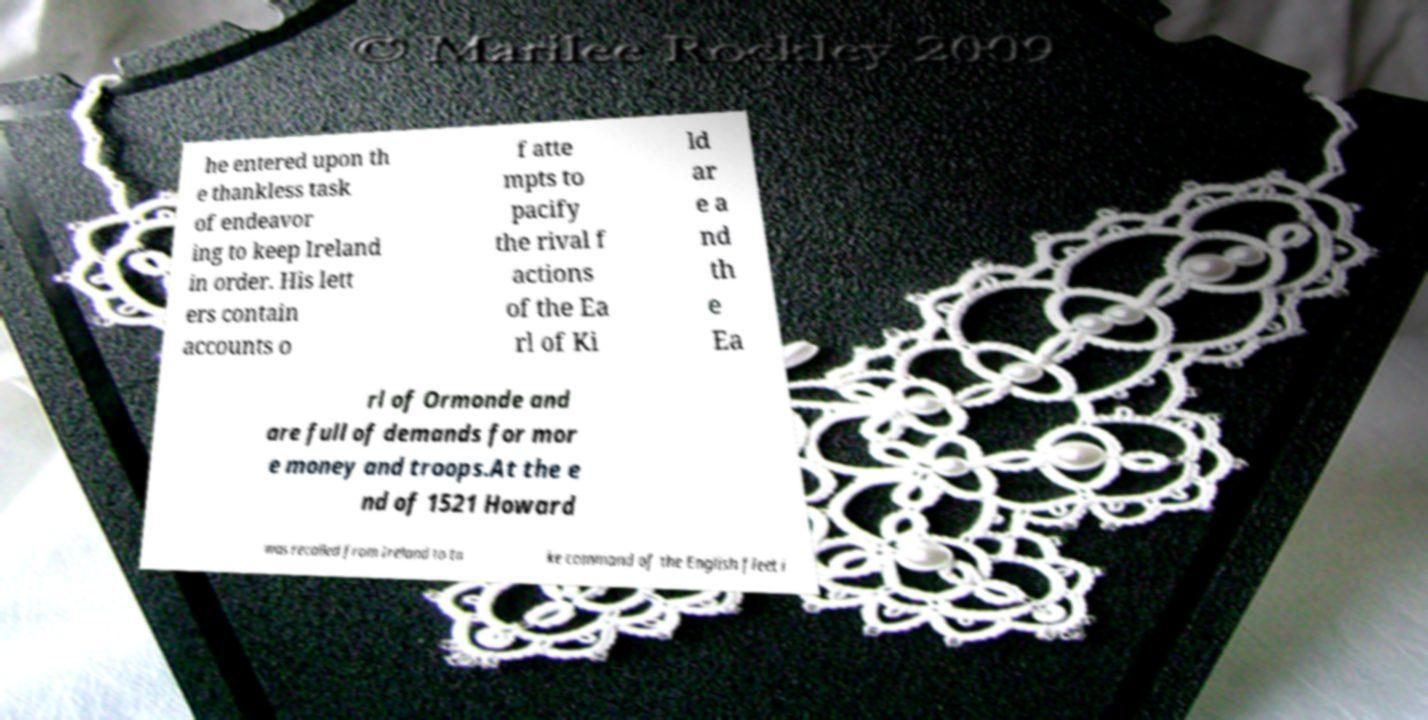Can you accurately transcribe the text from the provided image for me? he entered upon th e thankless task of endeavor ing to keep Ireland in order. His lett ers contain accounts o f atte mpts to pacify the rival f actions of the Ea rl of Ki ld ar e a nd th e Ea rl of Ormonde and are full of demands for mor e money and troops.At the e nd of 1521 Howard was recalled from Ireland to ta ke command of the English fleet i 